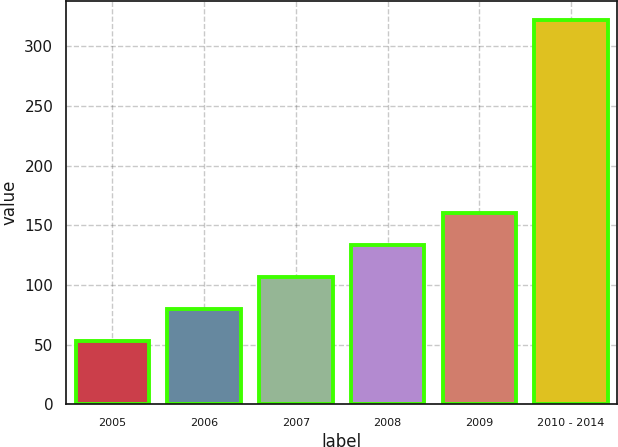Convert chart. <chart><loc_0><loc_0><loc_500><loc_500><bar_chart><fcel>2005<fcel>2006<fcel>2007<fcel>2008<fcel>2009<fcel>2010 - 2014<nl><fcel>53.2<fcel>80.05<fcel>106.9<fcel>133.75<fcel>160.6<fcel>321.7<nl></chart> 